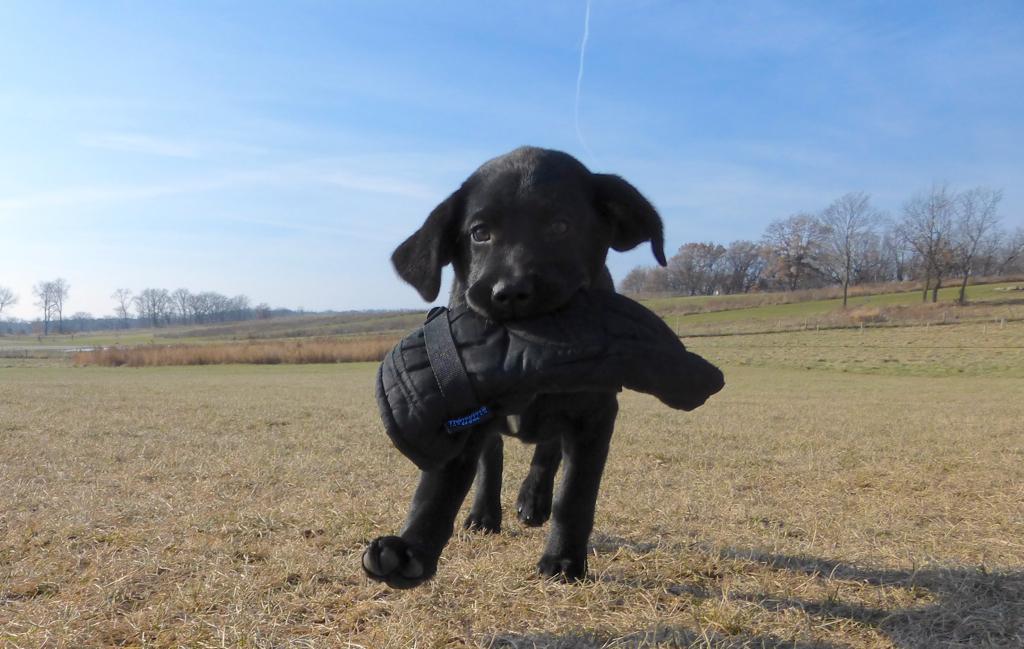Please provide a concise description of this image. In this picture we can see a black dog on the dry grass. We can see a few trees on the right and left side of the image. Sky is blue in color. 